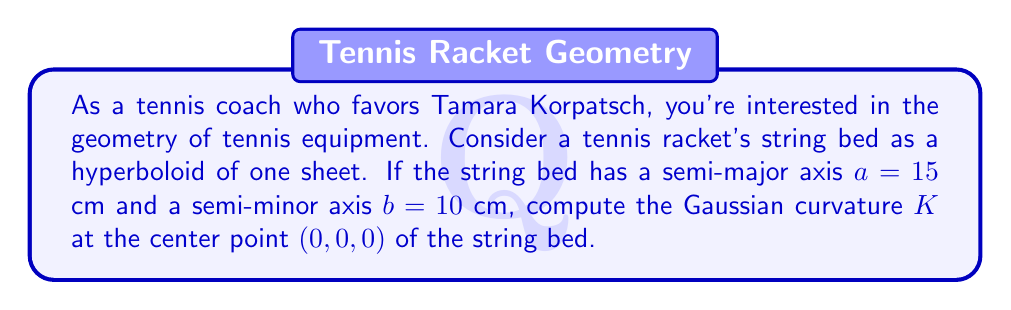Teach me how to tackle this problem. Let's approach this step-by-step:

1) The equation of a hyperboloid of one sheet is given by:

   $$\frac{x^2}{a^2} + \frac{y^2}{b^2} - \frac{z^2}{c^2} = 1$$

2) For our tennis racket string bed, we have $a=15$ cm and $b=10$ cm. Let's assume $c=12$ cm for the third axis. The equation becomes:

   $$\frac{x^2}{15^2} + \frac{y^2}{10^2} - \frac{z^2}{12^2} = 1$$

3) To compute the Gaussian curvature, we need to find the coefficients of the first and second fundamental forms. Let's parameterize the surface:

   $$x = 15 \cosh u \cos v$$
   $$y = 10 \cosh u \sin v$$
   $$z = 12 \sinh u$$

4) The partial derivatives are:

   $$x_u = 15 \sinh u \cos v, \quad x_v = -15 \cosh u \sin v$$
   $$y_u = 10 \sinh u \sin v, \quad y_v = 10 \cosh u \cos v$$
   $$z_u = 12 \cosh u, \quad z_v = 0$$

5) The coefficients of the first fundamental form at $(0,0,0)$ are:

   $$E = x_u^2 + y_u^2 + z_u^2 = 15^2 + 10^2 + 12^2 = 529$$
   $$F = x_u x_v + y_u y_v + z_u z_v = 0$$
   $$G = x_v^2 + y_v^2 + z_v^2 = 15^2 + 10^2 = 325$$

6) For the second fundamental form, we need the second partial derivatives:

   $$x_{uu} = 15 \cosh u \cos v, \quad x_{uv} = -15 \sinh u \sin v, \quad x_{vv} = -15 \cosh u \cos v$$
   $$y_{uu} = 10 \cosh u \sin v, \quad y_{uv} = 10 \sinh u \cos v, \quad y_{vv} = -10 \cosh u \sin v$$
   $$z_{uu} = 12 \sinh u, \quad z_{uv} = 0, \quad z_{vv} = 0$$

7) The unit normal vector at $(0,0,0)$ is:

   $$\vec{N} = (0, 0, 1)$$

8) The coefficients of the second fundamental form at $(0,0,0)$ are:

   $$L = x_{uu}N_x + y_{uu}N_y + z_{uu}N_z = 0$$
   $$M = x_{uv}N_x + y_{uv}N_y + z_{uv}N_z = 0$$
   $$N = x_{vv}N_x + y_{vv}N_y + z_{vv}N_z = 0$$

9) The Gaussian curvature is given by:

   $$K = \frac{LN - M^2}{EG - F^2}$$

10) Substituting the values:

    $$K = \frac{0 \cdot 0 - 0^2}{529 \cdot 325 - 0^2} = 0$$

Therefore, the Gaussian curvature at the center point of the string bed is 0.
Answer: $K = 0$ 